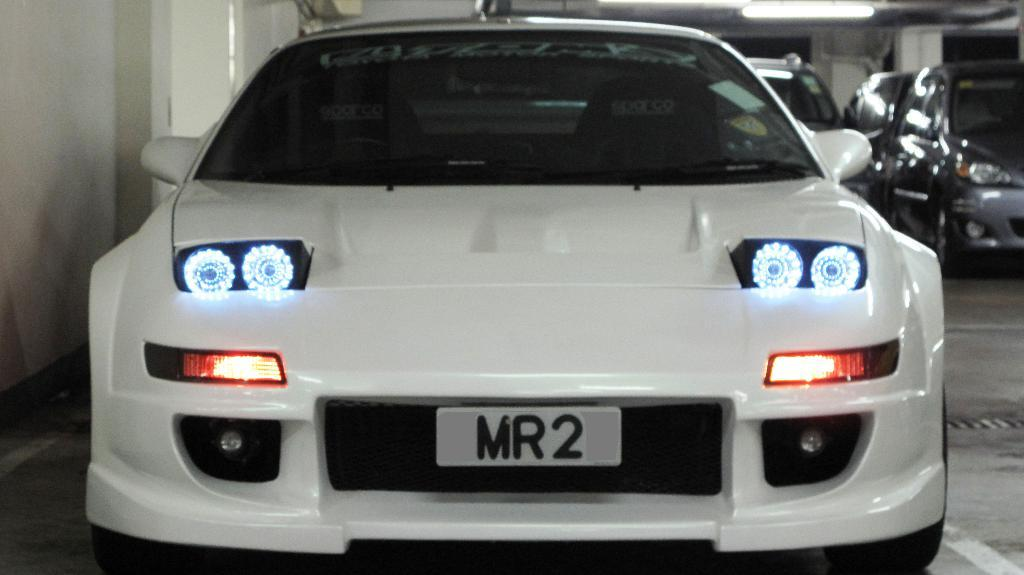What type of objects are present in the image? There are vehicles in the image. What specific features can be observed on the vehicles? The vehicles have number plates and headlights. Can you identify any other light source in the image? Yes, there is a tube light visible in the image. How many mice can be seen running on the vehicles in the image? There are no mice present in the image; it features vehicles with number plates and headlights, along with a visible tube light. What type of teeth can be seen on the vehicles in the image? Vehicles do not have teeth, so this question cannot be answered based on the image. 